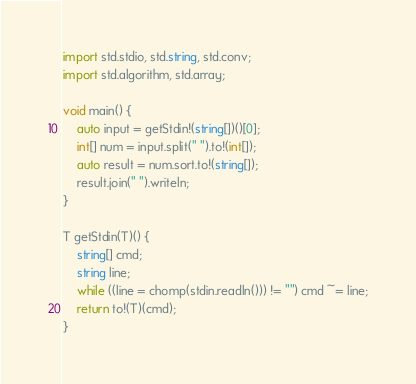<code> <loc_0><loc_0><loc_500><loc_500><_D_>import std.stdio, std.string, std.conv;
import std.algorithm, std.array;

void main() {
	auto input = getStdin!(string[])()[0];
	int[] num = input.split(" ").to!(int[]);
	auto result = num.sort.to!(string[]);
	result.join(" ").writeln;
}

T getStdin(T)() {
    string[] cmd;
    string line;
    while ((line = chomp(stdin.readln())) != "") cmd ~= line;
    return to!(T)(cmd);
}</code> 